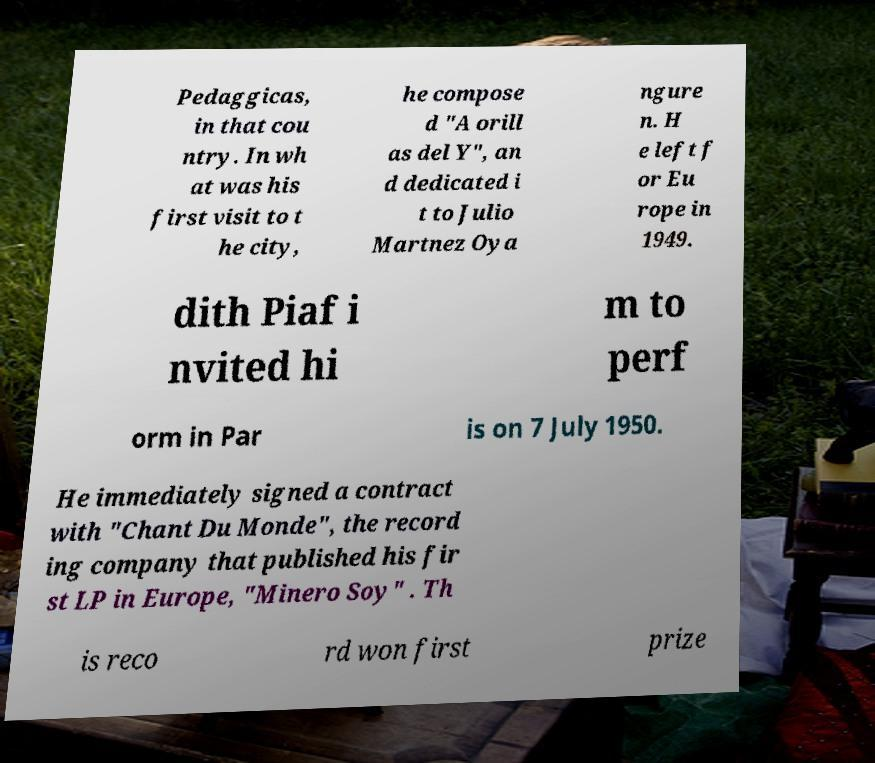There's text embedded in this image that I need extracted. Can you transcribe it verbatim? Pedaggicas, in that cou ntry. In wh at was his first visit to t he city, he compose d "A orill as del Y", an d dedicated i t to Julio Martnez Oya ngure n. H e left f or Eu rope in 1949. dith Piaf i nvited hi m to perf orm in Par is on 7 July 1950. He immediately signed a contract with "Chant Du Monde", the record ing company that published his fir st LP in Europe, "Minero Soy" . Th is reco rd won first prize 